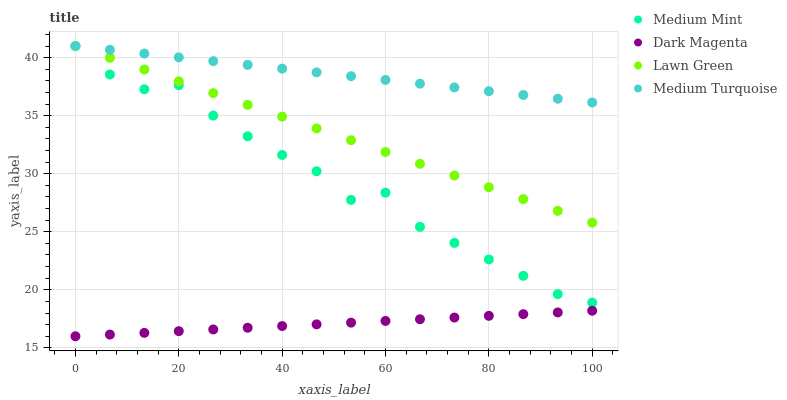Does Dark Magenta have the minimum area under the curve?
Answer yes or no. Yes. Does Medium Turquoise have the maximum area under the curve?
Answer yes or no. Yes. Does Lawn Green have the minimum area under the curve?
Answer yes or no. No. Does Lawn Green have the maximum area under the curve?
Answer yes or no. No. Is Dark Magenta the smoothest?
Answer yes or no. Yes. Is Medium Mint the roughest?
Answer yes or no. Yes. Is Lawn Green the smoothest?
Answer yes or no. No. Is Lawn Green the roughest?
Answer yes or no. No. Does Dark Magenta have the lowest value?
Answer yes or no. Yes. Does Lawn Green have the lowest value?
Answer yes or no. No. Does Medium Turquoise have the highest value?
Answer yes or no. Yes. Does Dark Magenta have the highest value?
Answer yes or no. No. Is Dark Magenta less than Medium Mint?
Answer yes or no. Yes. Is Medium Mint greater than Dark Magenta?
Answer yes or no. Yes. Does Medium Turquoise intersect Lawn Green?
Answer yes or no. Yes. Is Medium Turquoise less than Lawn Green?
Answer yes or no. No. Is Medium Turquoise greater than Lawn Green?
Answer yes or no. No. Does Dark Magenta intersect Medium Mint?
Answer yes or no. No. 